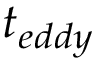Convert formula to latex. <formula><loc_0><loc_0><loc_500><loc_500>t _ { e d d y }</formula> 